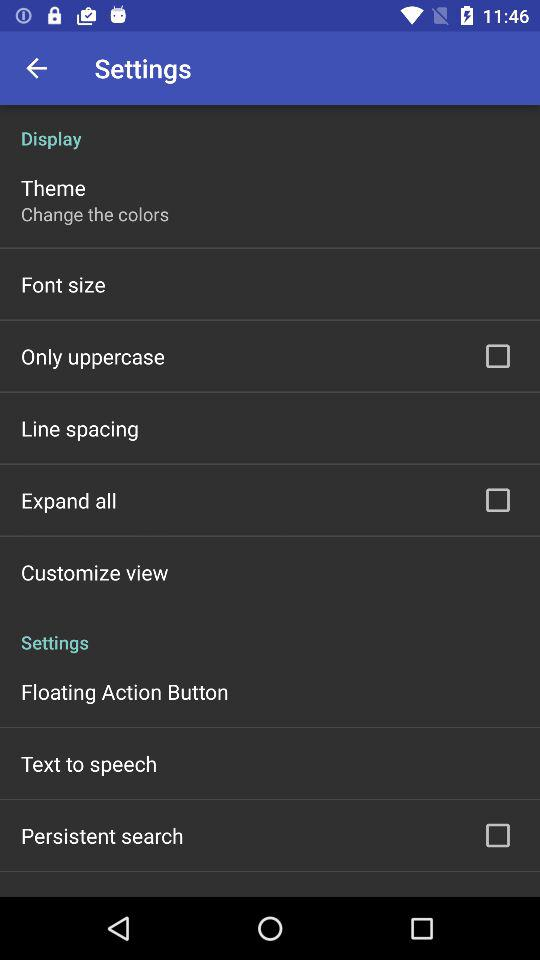How many options in the Display section have a checkbox?
Answer the question using a single word or phrase. 2 